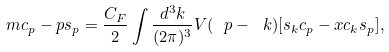Convert formula to latex. <formula><loc_0><loc_0><loc_500><loc_500>m c _ { p } - p s _ { p } = \frac { C _ { F } } { 2 } \int \frac { d ^ { 3 } k } { ( 2 \pi ) ^ { 3 } } V ( \ p - \ k ) [ s _ { k } c _ { p } - x c _ { k } s _ { p } ] ,</formula> 